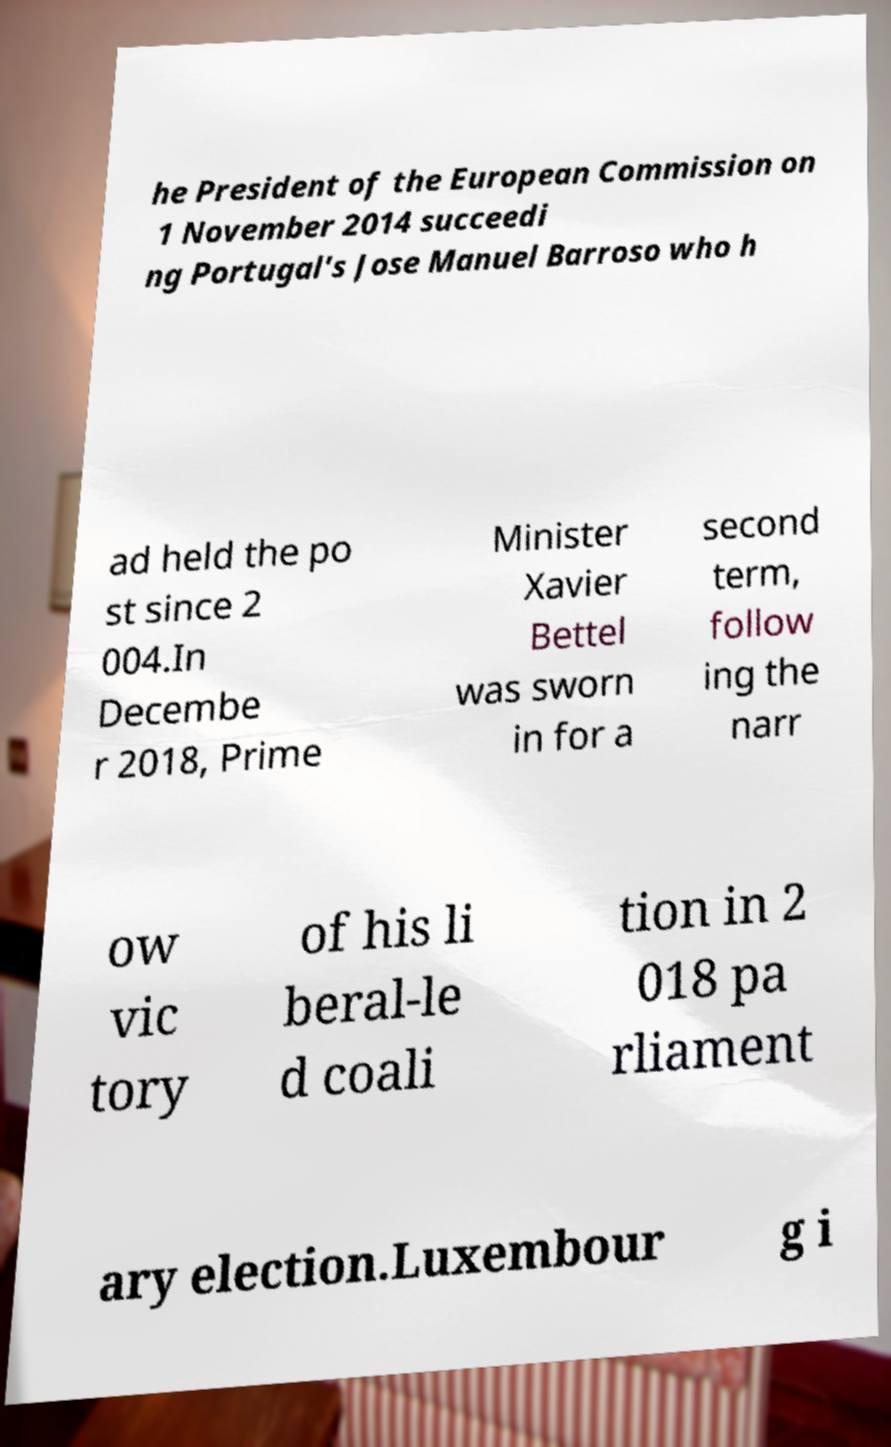For documentation purposes, I need the text within this image transcribed. Could you provide that? he President of the European Commission on 1 November 2014 succeedi ng Portugal's Jose Manuel Barroso who h ad held the po st since 2 004.In Decembe r 2018, Prime Minister Xavier Bettel was sworn in for a second term, follow ing the narr ow vic tory of his li beral-le d coali tion in 2 018 pa rliament ary election.Luxembour g i 